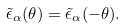<formula> <loc_0><loc_0><loc_500><loc_500>\tilde { \epsilon } _ { \alpha } ( \theta ) = \tilde { \epsilon } _ { \alpha } ( - \theta ) .</formula> 